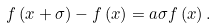<formula> <loc_0><loc_0><loc_500><loc_500>f \left ( x + \sigma \right ) - f \left ( x \right ) = a \sigma f \left ( x \right ) .</formula> 